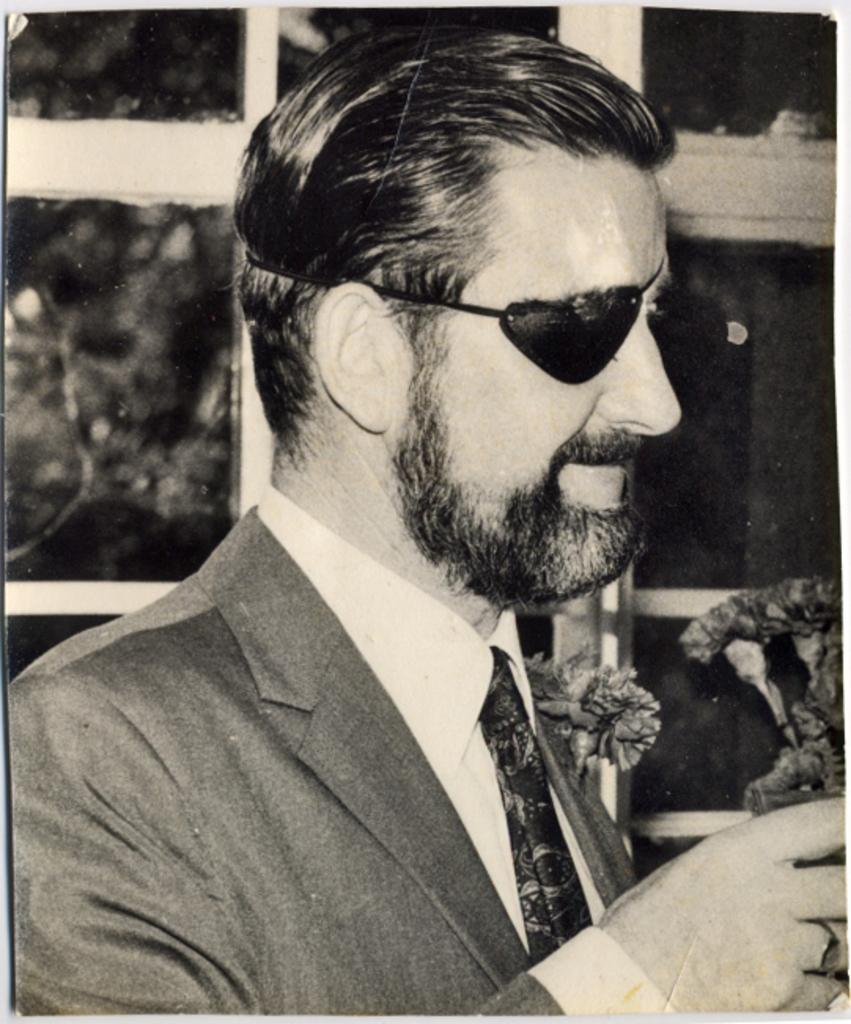What is featured on the poster in the image? The facts provided do not specify what is on the poster. What is the person in the image wearing? The person in the image is wearing a suit and a one-eyed mask. What type of vegetation can be seen in the image? There are plants visible in the image. What architectural feature is present in the image? There are windows in the image. Where is the shelf located in the image? There is no shelf present in the image. What type of observation can be made from the throne in the image? There is no throne present in the image. 